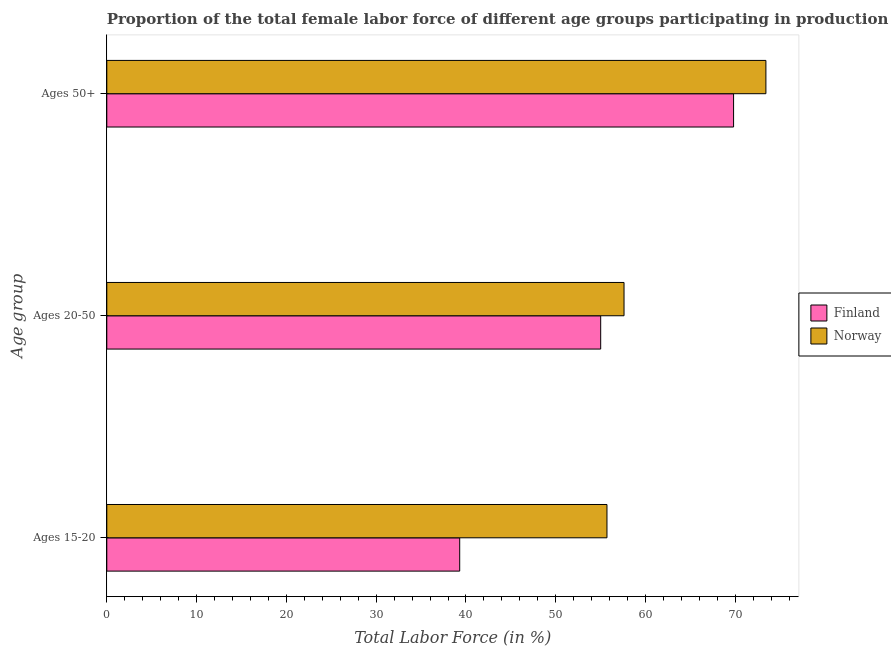How many different coloured bars are there?
Your answer should be very brief. 2. How many groups of bars are there?
Provide a short and direct response. 3. Are the number of bars per tick equal to the number of legend labels?
Give a very brief answer. Yes. Are the number of bars on each tick of the Y-axis equal?
Provide a succinct answer. Yes. What is the label of the 3rd group of bars from the top?
Provide a short and direct response. Ages 15-20. What is the percentage of female labor force above age 50 in Finland?
Keep it short and to the point. 69.8. Across all countries, what is the maximum percentage of female labor force within the age group 20-50?
Make the answer very short. 57.6. Across all countries, what is the minimum percentage of female labor force within the age group 15-20?
Provide a short and direct response. 39.3. In which country was the percentage of female labor force above age 50 maximum?
Your answer should be compact. Norway. What is the total percentage of female labor force above age 50 in the graph?
Provide a short and direct response. 143.2. What is the difference between the percentage of female labor force above age 50 in Norway and that in Finland?
Offer a very short reply. 3.6. What is the difference between the percentage of female labor force within the age group 20-50 in Finland and the percentage of female labor force within the age group 15-20 in Norway?
Offer a very short reply. -0.7. What is the average percentage of female labor force within the age group 15-20 per country?
Offer a very short reply. 47.5. What is the difference between the percentage of female labor force within the age group 15-20 and percentage of female labor force within the age group 20-50 in Norway?
Offer a terse response. -1.9. What is the ratio of the percentage of female labor force within the age group 20-50 in Finland to that in Norway?
Provide a short and direct response. 0.95. Is the percentage of female labor force within the age group 20-50 in Finland less than that in Norway?
Provide a short and direct response. Yes. Is the difference between the percentage of female labor force within the age group 15-20 in Finland and Norway greater than the difference between the percentage of female labor force within the age group 20-50 in Finland and Norway?
Your answer should be very brief. No. What is the difference between the highest and the second highest percentage of female labor force within the age group 20-50?
Your answer should be very brief. 2.6. What is the difference between the highest and the lowest percentage of female labor force above age 50?
Your response must be concise. 3.6. In how many countries, is the percentage of female labor force within the age group 20-50 greater than the average percentage of female labor force within the age group 20-50 taken over all countries?
Provide a succinct answer. 1. What does the 1st bar from the bottom in Ages 20-50 represents?
Keep it short and to the point. Finland. Are all the bars in the graph horizontal?
Make the answer very short. Yes. Are the values on the major ticks of X-axis written in scientific E-notation?
Your answer should be very brief. No. What is the title of the graph?
Ensure brevity in your answer.  Proportion of the total female labor force of different age groups participating in production in 1996. Does "China" appear as one of the legend labels in the graph?
Provide a succinct answer. No. What is the label or title of the Y-axis?
Offer a very short reply. Age group. What is the Total Labor Force (in %) in Finland in Ages 15-20?
Your answer should be compact. 39.3. What is the Total Labor Force (in %) of Norway in Ages 15-20?
Your answer should be very brief. 55.7. What is the Total Labor Force (in %) of Norway in Ages 20-50?
Provide a short and direct response. 57.6. What is the Total Labor Force (in %) of Finland in Ages 50+?
Offer a very short reply. 69.8. What is the Total Labor Force (in %) of Norway in Ages 50+?
Offer a terse response. 73.4. Across all Age group, what is the maximum Total Labor Force (in %) of Finland?
Offer a very short reply. 69.8. Across all Age group, what is the maximum Total Labor Force (in %) of Norway?
Offer a terse response. 73.4. Across all Age group, what is the minimum Total Labor Force (in %) of Finland?
Make the answer very short. 39.3. Across all Age group, what is the minimum Total Labor Force (in %) of Norway?
Your answer should be compact. 55.7. What is the total Total Labor Force (in %) of Finland in the graph?
Your answer should be very brief. 164.1. What is the total Total Labor Force (in %) in Norway in the graph?
Your answer should be very brief. 186.7. What is the difference between the Total Labor Force (in %) in Finland in Ages 15-20 and that in Ages 20-50?
Make the answer very short. -15.7. What is the difference between the Total Labor Force (in %) in Finland in Ages 15-20 and that in Ages 50+?
Your answer should be compact. -30.5. What is the difference between the Total Labor Force (in %) of Norway in Ages 15-20 and that in Ages 50+?
Ensure brevity in your answer.  -17.7. What is the difference between the Total Labor Force (in %) in Finland in Ages 20-50 and that in Ages 50+?
Offer a very short reply. -14.8. What is the difference between the Total Labor Force (in %) in Norway in Ages 20-50 and that in Ages 50+?
Provide a short and direct response. -15.8. What is the difference between the Total Labor Force (in %) of Finland in Ages 15-20 and the Total Labor Force (in %) of Norway in Ages 20-50?
Your response must be concise. -18.3. What is the difference between the Total Labor Force (in %) in Finland in Ages 15-20 and the Total Labor Force (in %) in Norway in Ages 50+?
Keep it short and to the point. -34.1. What is the difference between the Total Labor Force (in %) in Finland in Ages 20-50 and the Total Labor Force (in %) in Norway in Ages 50+?
Your answer should be very brief. -18.4. What is the average Total Labor Force (in %) of Finland per Age group?
Provide a short and direct response. 54.7. What is the average Total Labor Force (in %) in Norway per Age group?
Ensure brevity in your answer.  62.23. What is the difference between the Total Labor Force (in %) in Finland and Total Labor Force (in %) in Norway in Ages 15-20?
Provide a short and direct response. -16.4. What is the difference between the Total Labor Force (in %) in Finland and Total Labor Force (in %) in Norway in Ages 20-50?
Keep it short and to the point. -2.6. What is the difference between the Total Labor Force (in %) in Finland and Total Labor Force (in %) in Norway in Ages 50+?
Keep it short and to the point. -3.6. What is the ratio of the Total Labor Force (in %) of Finland in Ages 15-20 to that in Ages 20-50?
Offer a terse response. 0.71. What is the ratio of the Total Labor Force (in %) in Norway in Ages 15-20 to that in Ages 20-50?
Your answer should be very brief. 0.97. What is the ratio of the Total Labor Force (in %) in Finland in Ages 15-20 to that in Ages 50+?
Keep it short and to the point. 0.56. What is the ratio of the Total Labor Force (in %) in Norway in Ages 15-20 to that in Ages 50+?
Your answer should be compact. 0.76. What is the ratio of the Total Labor Force (in %) in Finland in Ages 20-50 to that in Ages 50+?
Provide a succinct answer. 0.79. What is the ratio of the Total Labor Force (in %) of Norway in Ages 20-50 to that in Ages 50+?
Make the answer very short. 0.78. What is the difference between the highest and the lowest Total Labor Force (in %) in Finland?
Keep it short and to the point. 30.5. 